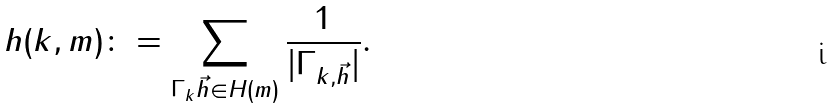Convert formula to latex. <formula><loc_0><loc_0><loc_500><loc_500>h ( k , m ) \colon = \sum _ { \Gamma _ { k } \vec { h } \in H ( m ) } \frac { 1 } { | \Gamma _ { k , \vec { h } } | } .</formula> 